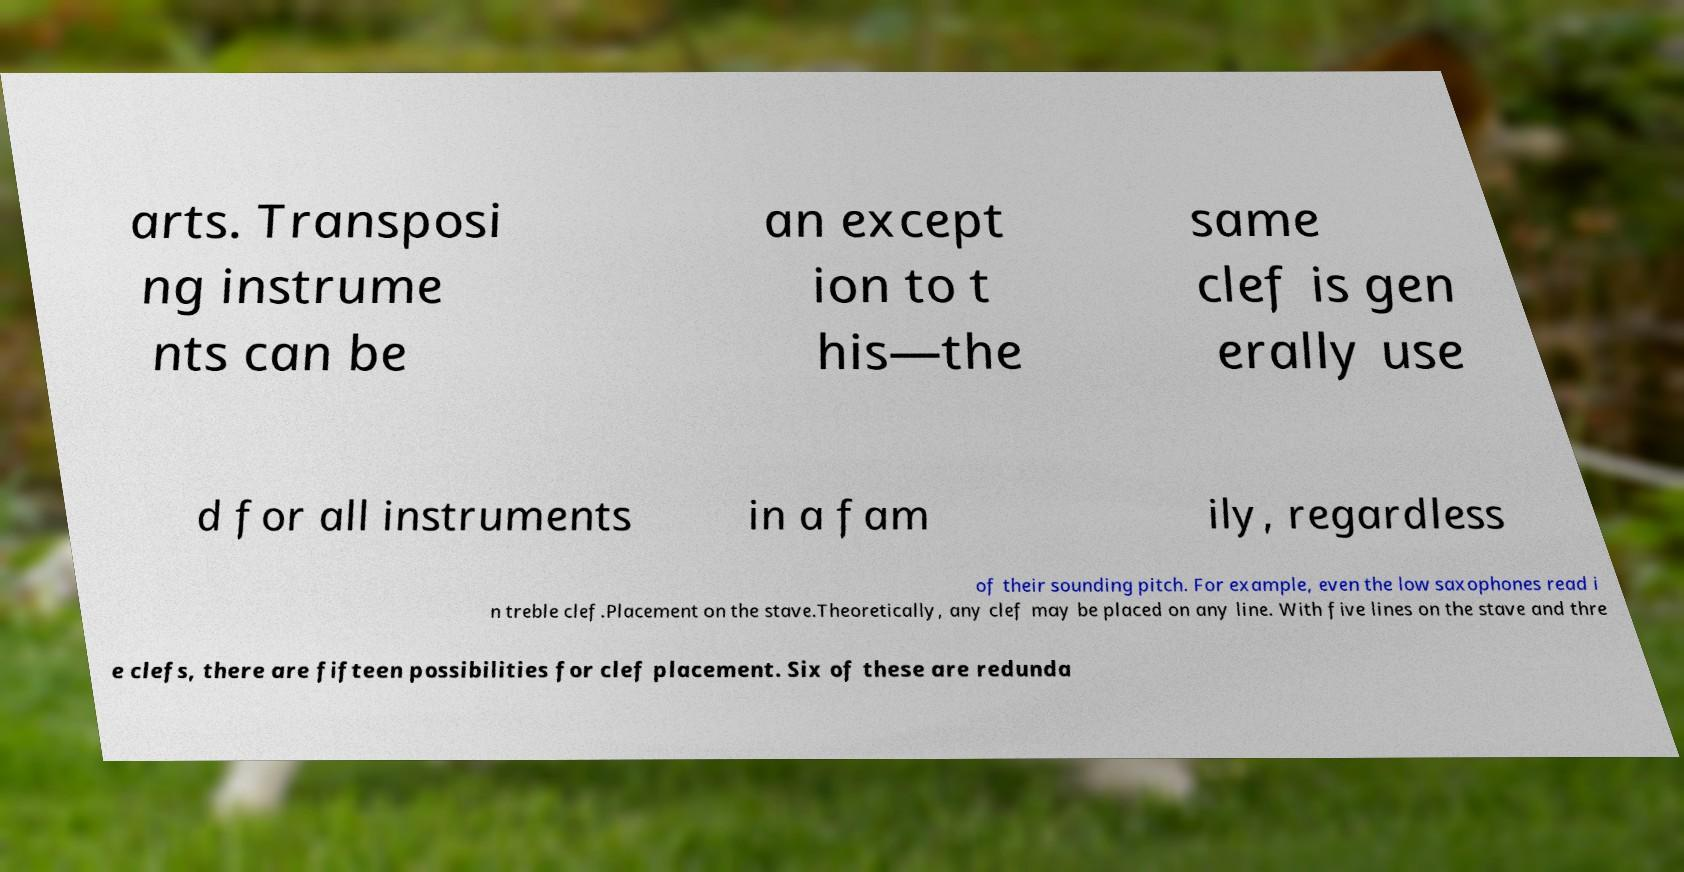Please read and relay the text visible in this image. What does it say? arts. Transposi ng instrume nts can be an except ion to t his—the same clef is gen erally use d for all instruments in a fam ily, regardless of their sounding pitch. For example, even the low saxophones read i n treble clef.Placement on the stave.Theoretically, any clef may be placed on any line. With five lines on the stave and thre e clefs, there are fifteen possibilities for clef placement. Six of these are redunda 